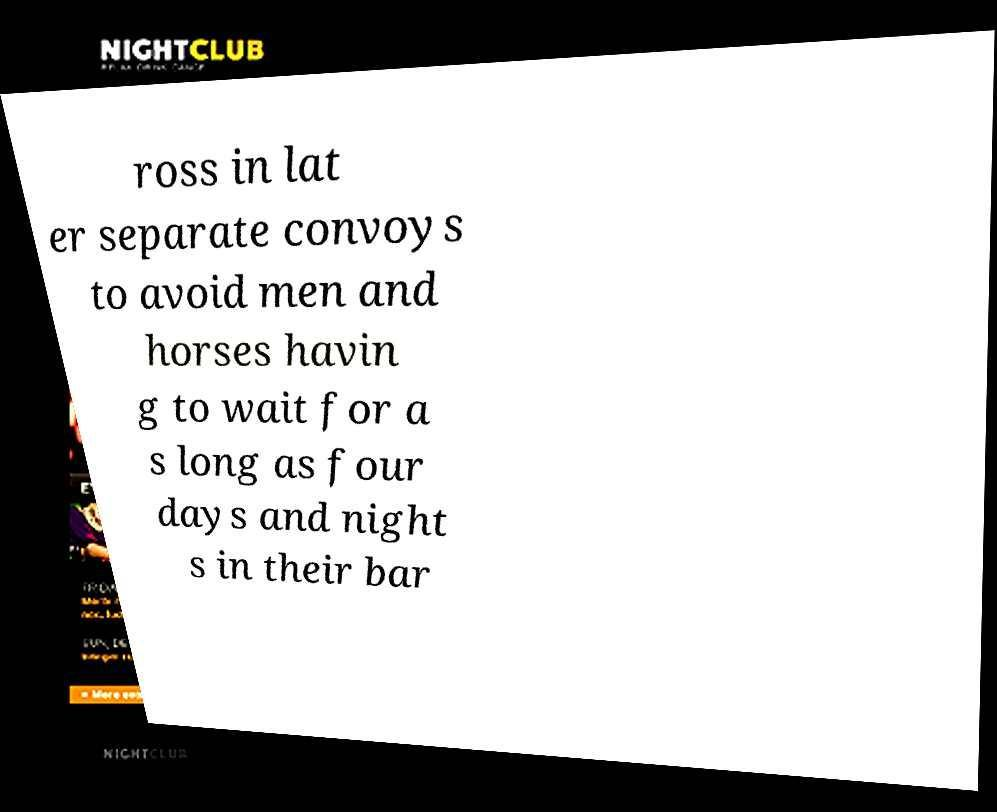Could you assist in decoding the text presented in this image and type it out clearly? ross in lat er separate convoys to avoid men and horses havin g to wait for a s long as four days and night s in their bar 